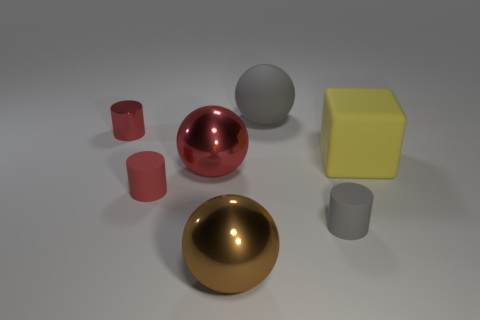What material is the large red object in front of the gray object that is behind the red ball?
Provide a short and direct response. Metal. Are there any red metal spheres that have the same size as the yellow rubber thing?
Offer a very short reply. Yes. What number of objects are metal objects to the right of the tiny red rubber cylinder or big metal balls that are in front of the tiny gray object?
Your answer should be very brief. 2. There is a gray thing behind the big yellow matte thing; does it have the same size as the brown metallic thing left of the yellow rubber thing?
Ensure brevity in your answer.  Yes. There is a yellow rubber object right of the brown thing; are there any red objects in front of it?
Offer a very short reply. Yes. What number of red objects are to the left of the small red metal object?
Keep it short and to the point. 0. How many other objects are the same color as the tiny metallic cylinder?
Your response must be concise. 2. Is the number of yellow cubes behind the large gray ball less than the number of yellow matte things that are behind the tiny gray rubber thing?
Your answer should be very brief. Yes. What number of objects are either things that are right of the shiny cylinder or big matte balls?
Ensure brevity in your answer.  6. There is a yellow rubber thing; is it the same size as the red matte cylinder that is in front of the metallic cylinder?
Your response must be concise. No. 